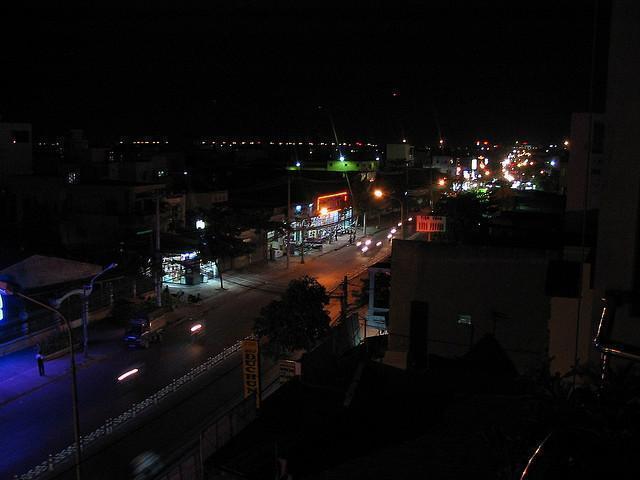What are is the image from?
Select the accurate answer and provide justification: `Answer: choice
Rationale: srationale.`
Options: Sky, city, underground, forest. Answer: city.
Rationale: The area has bright lights and many buildings. 